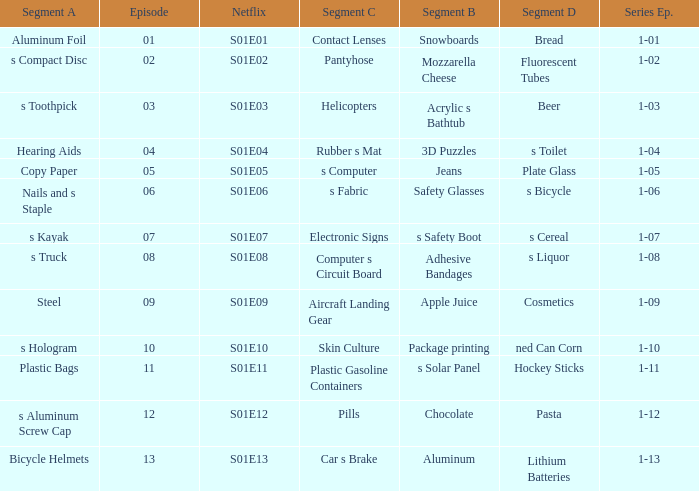What is the Netflix number having a series episode of 1-01? S01E01. 